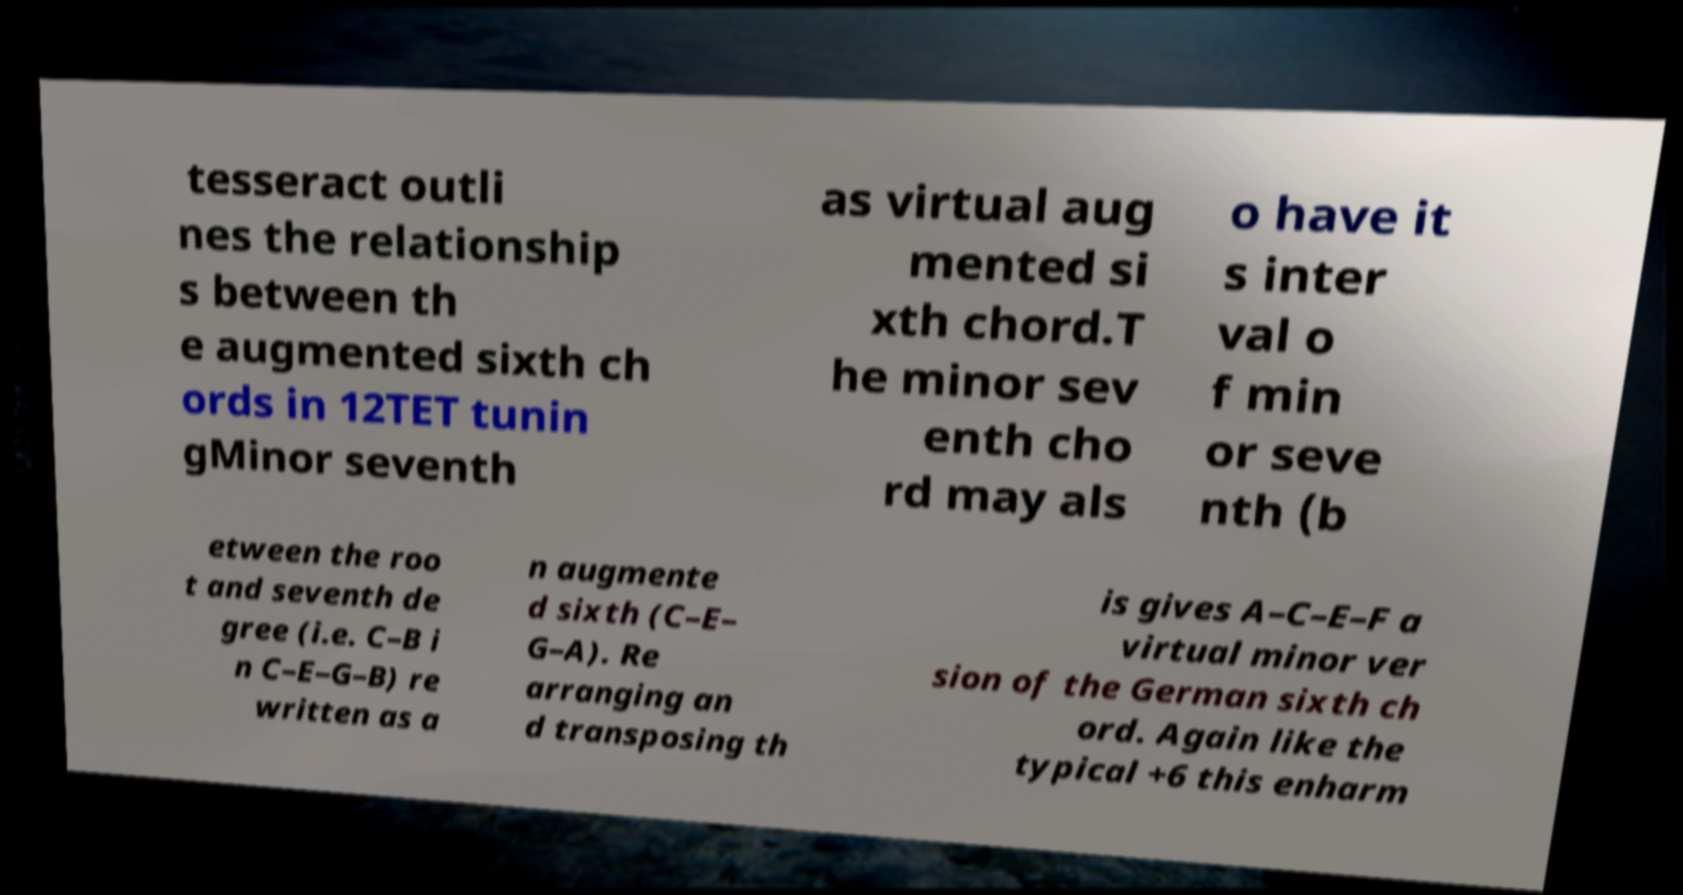Please read and relay the text visible in this image. What does it say? tesseract outli nes the relationship s between th e augmented sixth ch ords in 12TET tunin gMinor seventh as virtual aug mented si xth chord.T he minor sev enth cho rd may als o have it s inter val o f min or seve nth (b etween the roo t and seventh de gree (i.e. C–B i n C–E–G–B) re written as a n augmente d sixth (C–E– G–A). Re arranging an d transposing th is gives A–C–E–F a virtual minor ver sion of the German sixth ch ord. Again like the typical +6 this enharm 